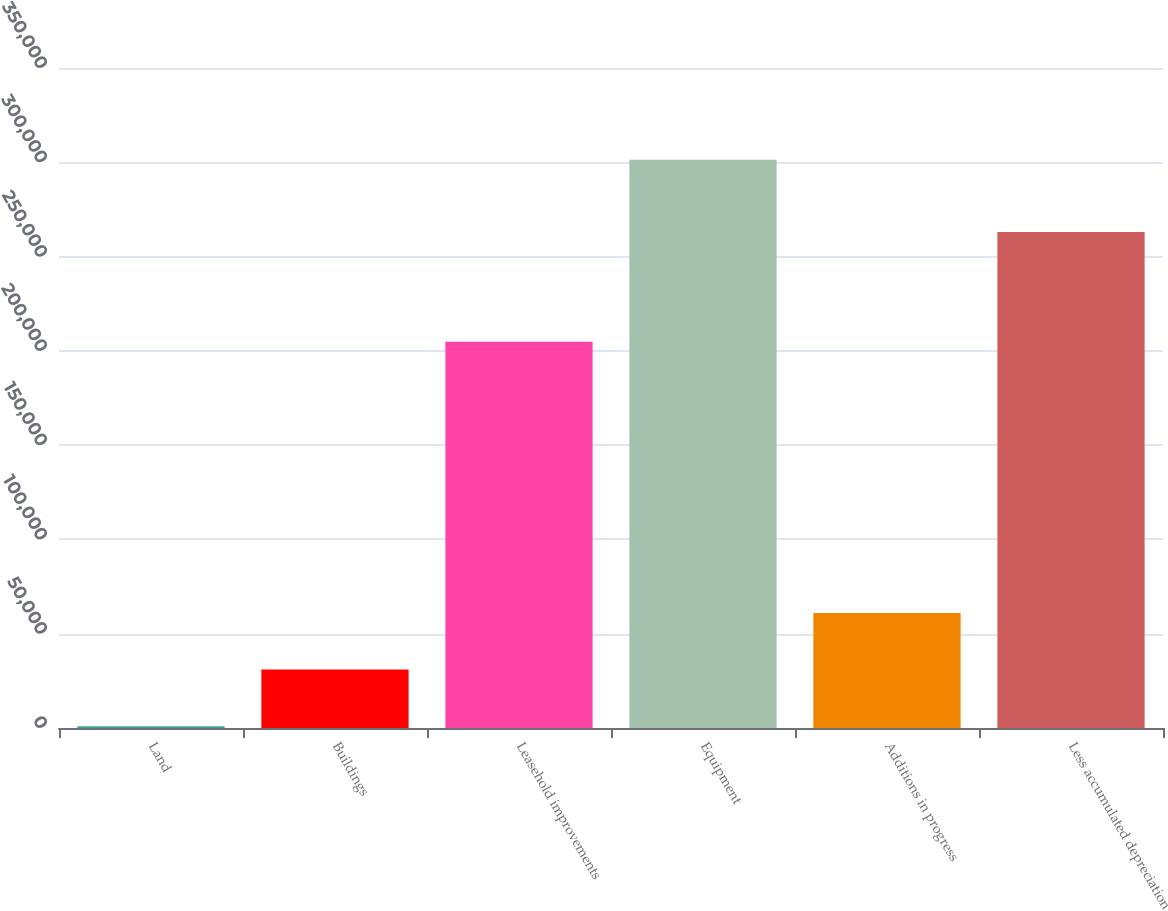Convert chart. <chart><loc_0><loc_0><loc_500><loc_500><bar_chart><fcel>Land<fcel>Buildings<fcel>Leasehold improvements<fcel>Equipment<fcel>Additions in progress<fcel>Less accumulated depreciation<nl><fcel>932<fcel>30967.3<fcel>204778<fcel>301285<fcel>61002.6<fcel>263070<nl></chart> 